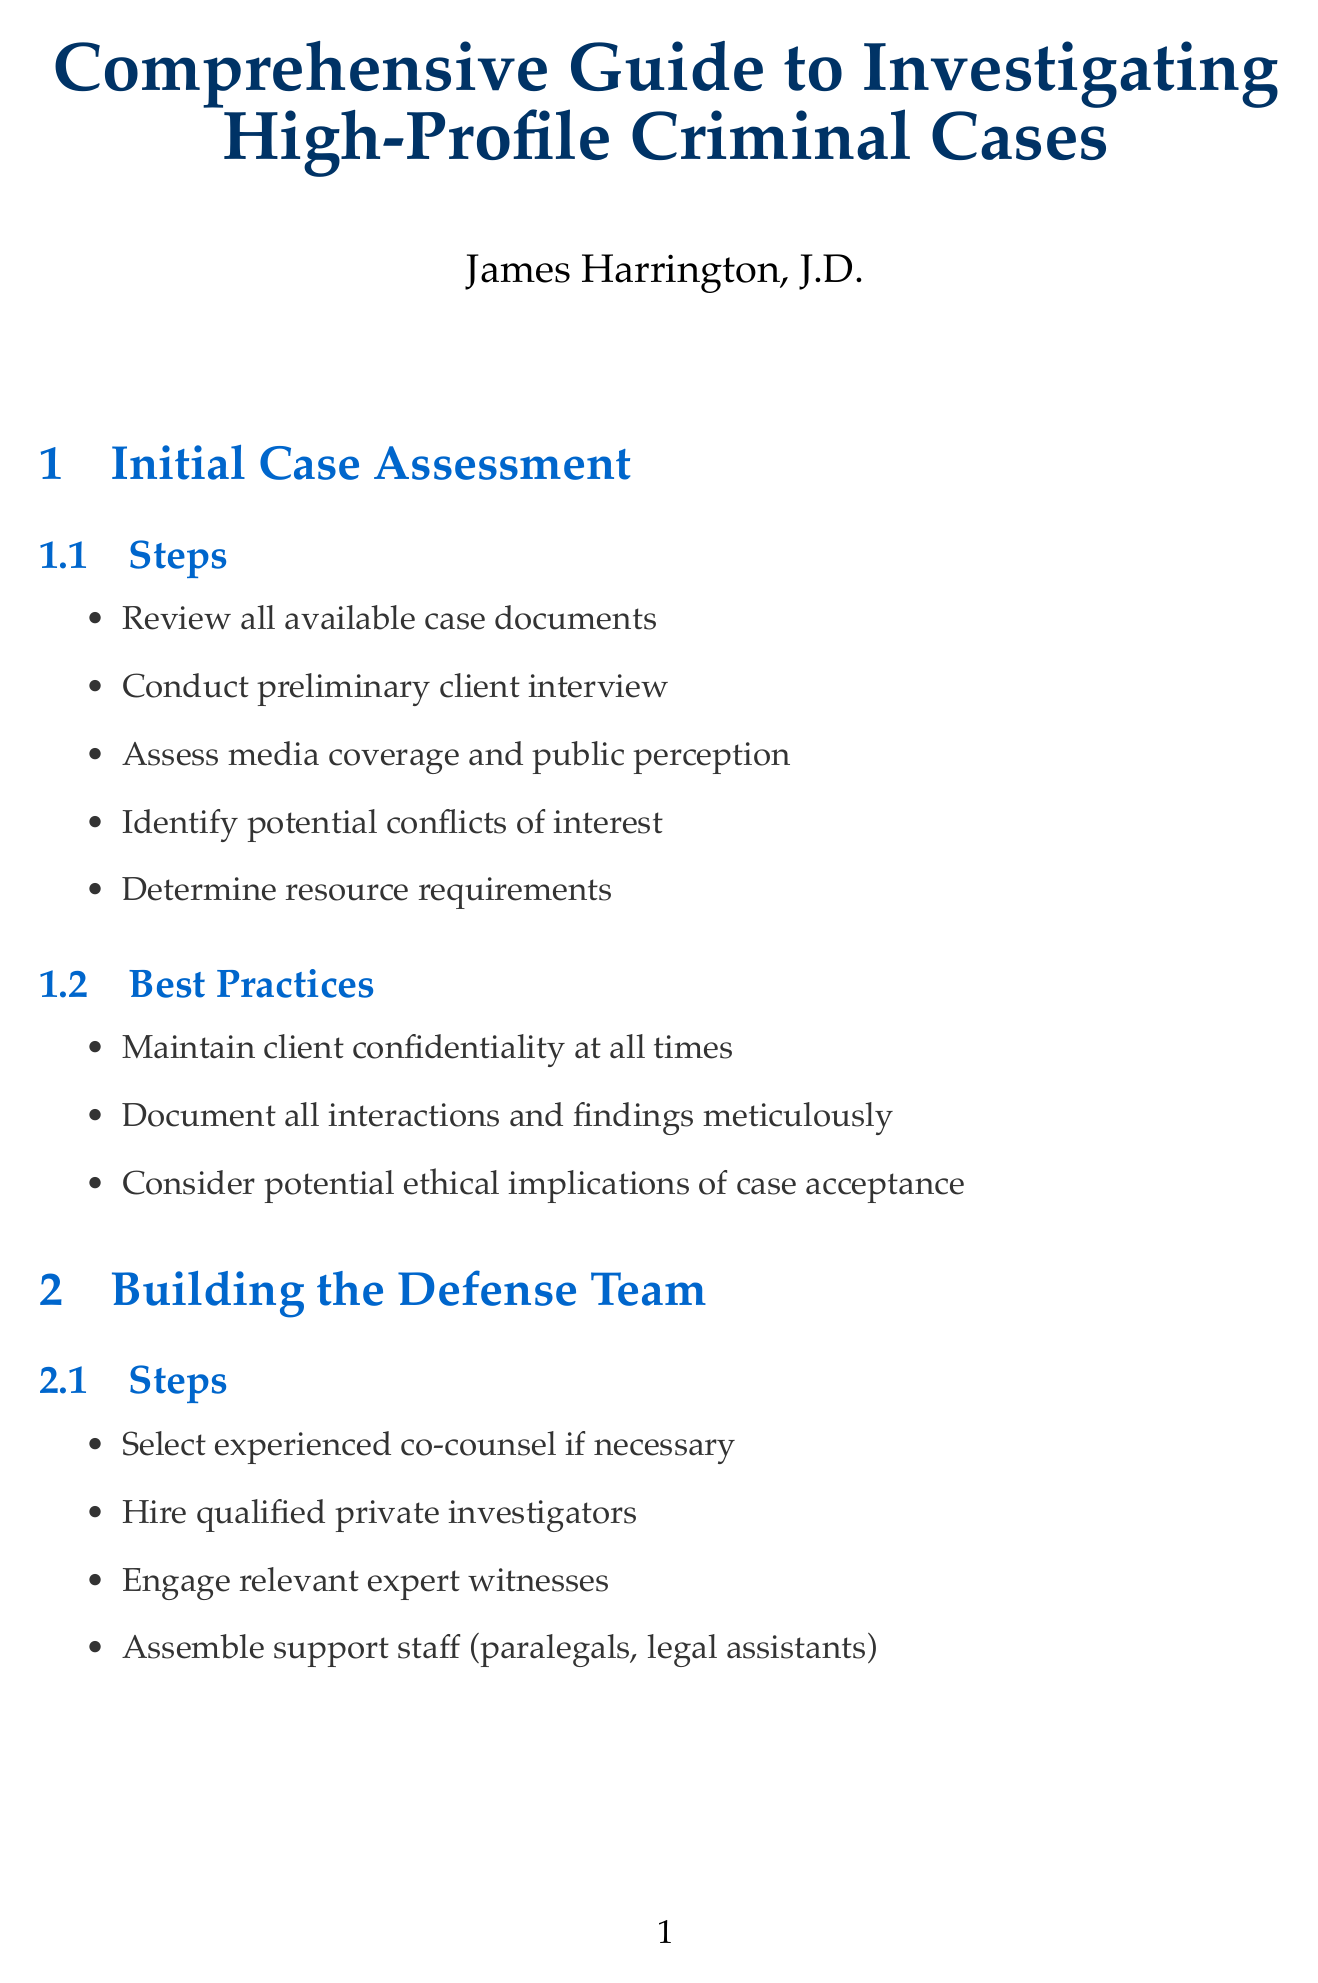What is the title of the manual? The title is stated at the beginning of the document, highlighting the main subject of the document.
Answer: Comprehensive Guide to Investigating High-Profile Criminal Cases Who is the author of the manual? The author is listed on the title page, indicating the person responsible for writing the guide.
Answer: James Harrington, J.D What step involves hiring experts? The steps in the relevant section detail activities required to develop a competent defense team, including engaging specialists.
Answer: Engage relevant expert witnesses What is one of the best practices for evidence collection? The best practices listed provide guidance on maintaining quality and legality during evidence gathering.
Answer: Maintain proper chain of custody for all evidence How many sections are in the manual? The sections are explicitly mentioned in the document, providing an overview of the manual's structure.
Answer: Eight What is a key aspect of witness interviews? The steps in witness interviews outline what should be done during the interviewing process.
Answer: Prepare comprehensive interview questions What is one checklist item for trial preparation? The checklist provides essential tasks that need to be completed before going to trial, ensuring readiness.
Answer: Witness preparation completed Which case is mentioned in the appendices? The appendices include significant legal precedents relevant to the investigative process.
Answer: Brady v. Maryland (1963) What is one useful resource referenced in the document? The useful resources listed support attorneys finding further information or guidelines related to their practice.
Answer: American Bar Association Criminal Justice Standards What should be done before accepting a case according to best practices? The best practices in the initial case assessment emphasize ethical considerations before beginning representation.
Answer: Consider potential ethical implications of case acceptance 